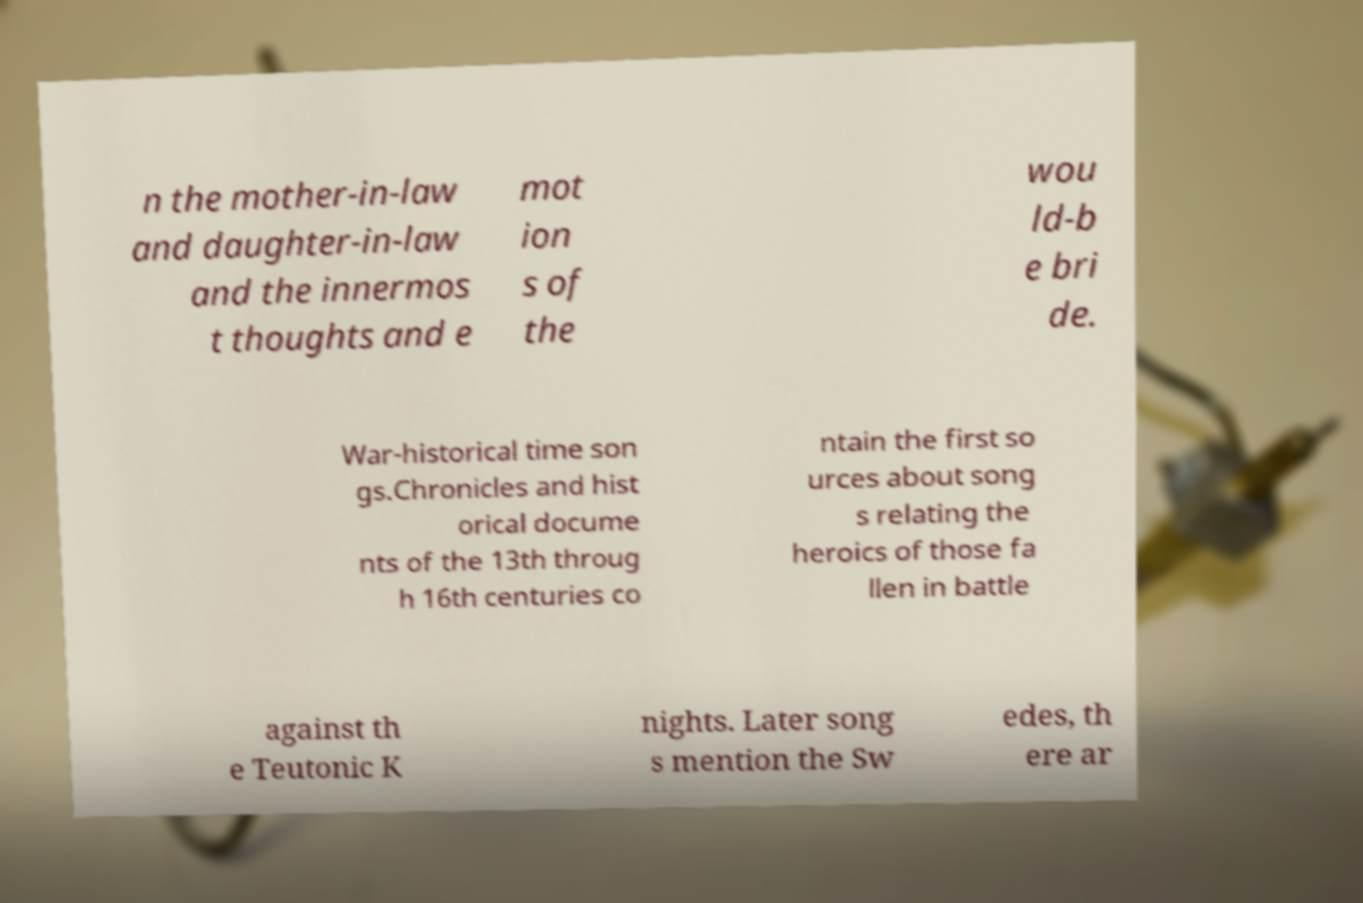There's text embedded in this image that I need extracted. Can you transcribe it verbatim? n the mother-in-law and daughter-in-law and the innermos t thoughts and e mot ion s of the wou ld-b e bri de. War-historical time son gs.Chronicles and hist orical docume nts of the 13th throug h 16th centuries co ntain the first so urces about song s relating the heroics of those fa llen in battle against th e Teutonic K nights. Later song s mention the Sw edes, th ere ar 